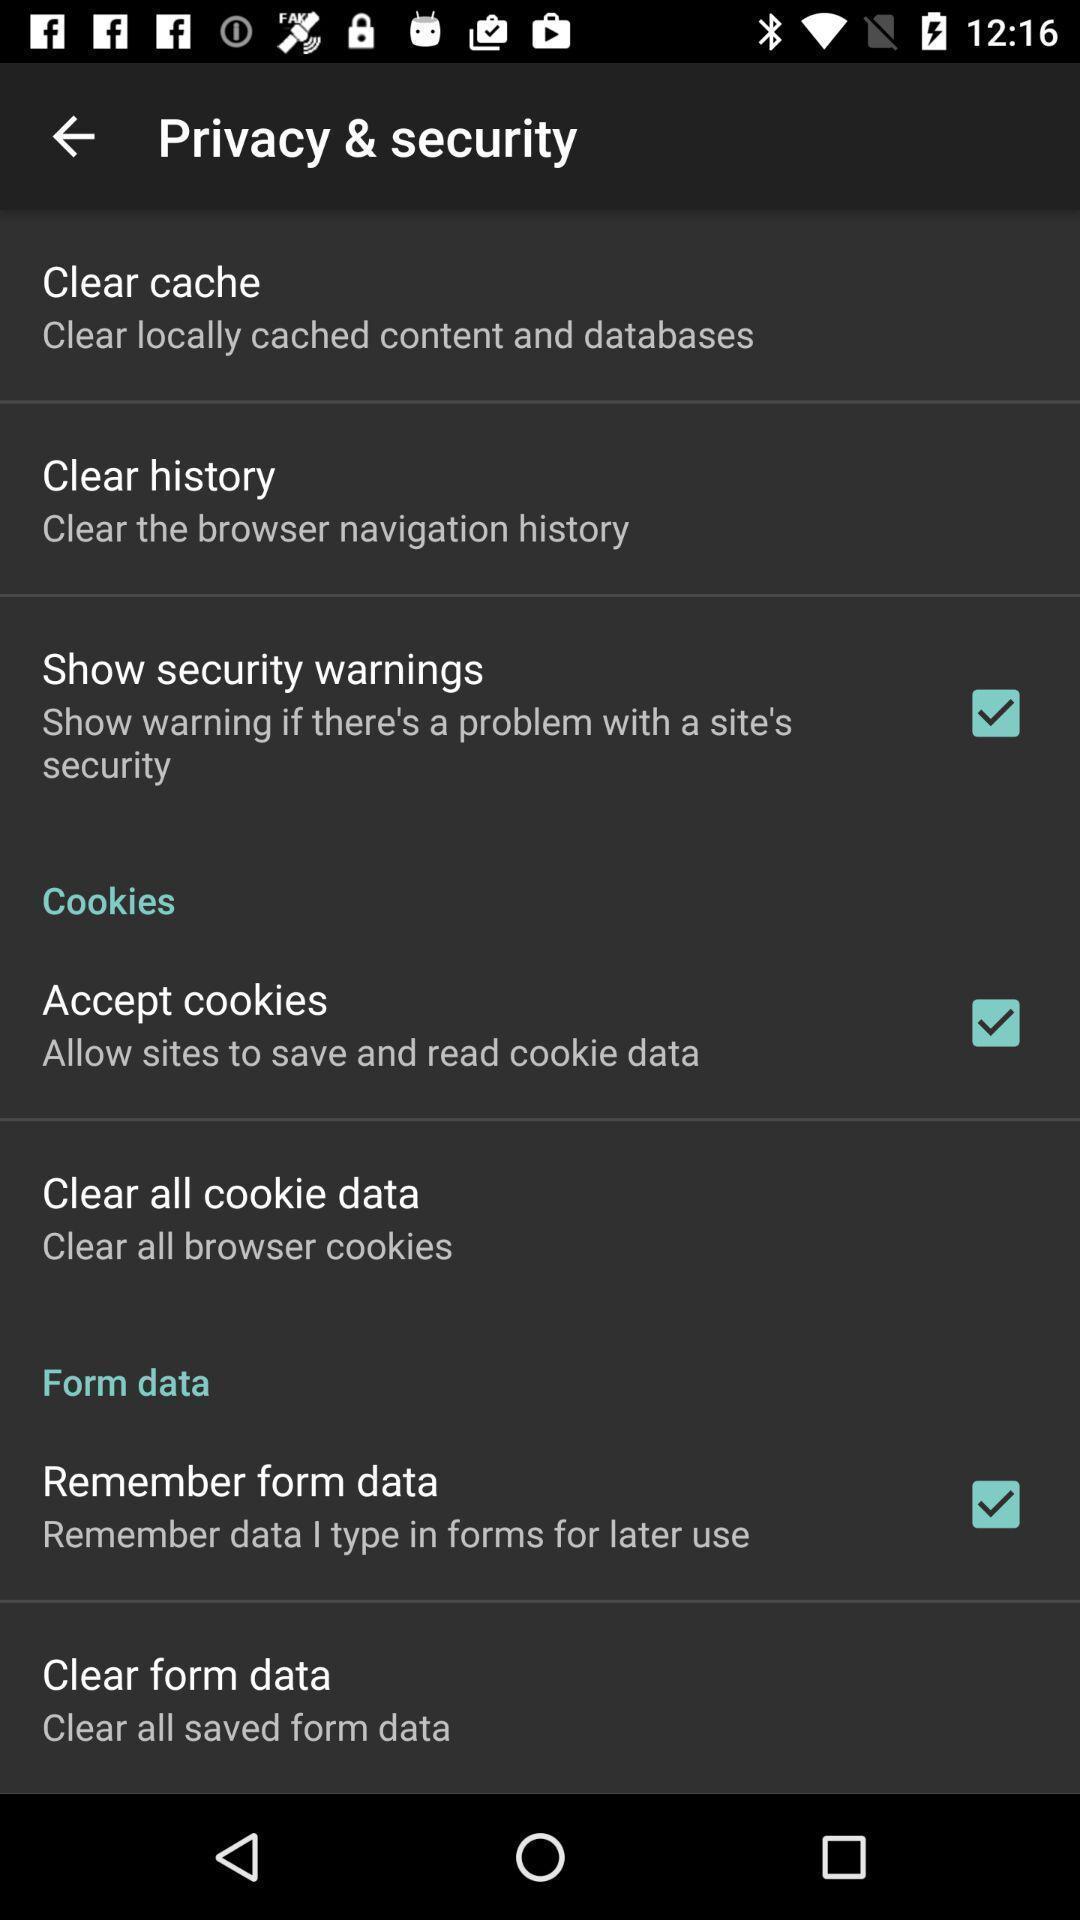Describe the content in this image. Settings page for setting of privacy and security. 